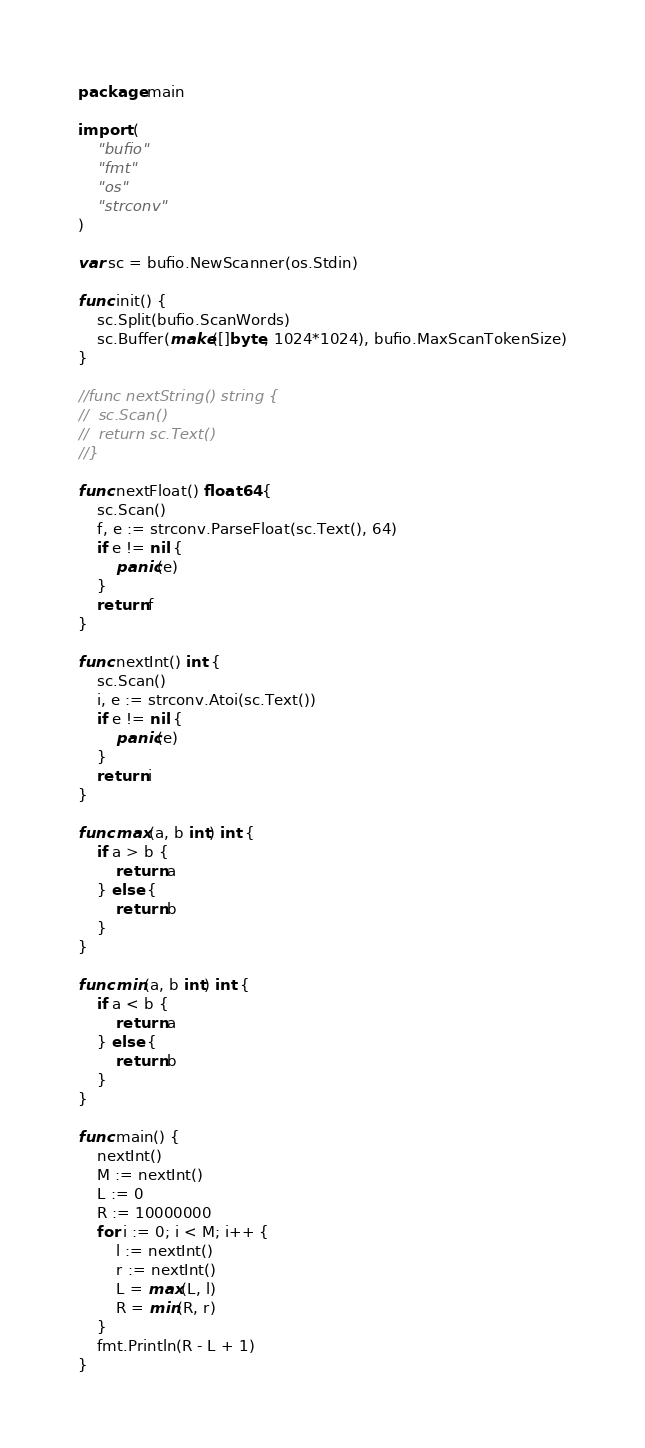<code> <loc_0><loc_0><loc_500><loc_500><_Go_>package main

import (
	"bufio"
	"fmt"
	"os"
	"strconv"
)

var sc = bufio.NewScanner(os.Stdin)

func init() {
	sc.Split(bufio.ScanWords)
	sc.Buffer(make([]byte, 1024*1024), bufio.MaxScanTokenSize)
}

//func nextString() string {
//	sc.Scan()
//	return sc.Text()
//}

func nextFloat() float64 {
	sc.Scan()
	f, e := strconv.ParseFloat(sc.Text(), 64)
	if e != nil {
		panic(e)
	}
	return f
}

func nextInt() int {
	sc.Scan()
	i, e := strconv.Atoi(sc.Text())
	if e != nil {
		panic(e)
	}
	return i
}

func max(a, b int) int {
	if a > b {
		return a
	} else {
		return b
	}
}

func min(a, b int) int {
	if a < b {
		return a
	} else {
		return b
	}
}

func main() {
	nextInt()
	M := nextInt()
	L := 0
	R := 10000000
	for i := 0; i < M; i++ {
		l := nextInt()
		r := nextInt()
		L = max(L, l)
		R = min(R, r)
	}
	fmt.Println(R - L + 1)
}
</code> 